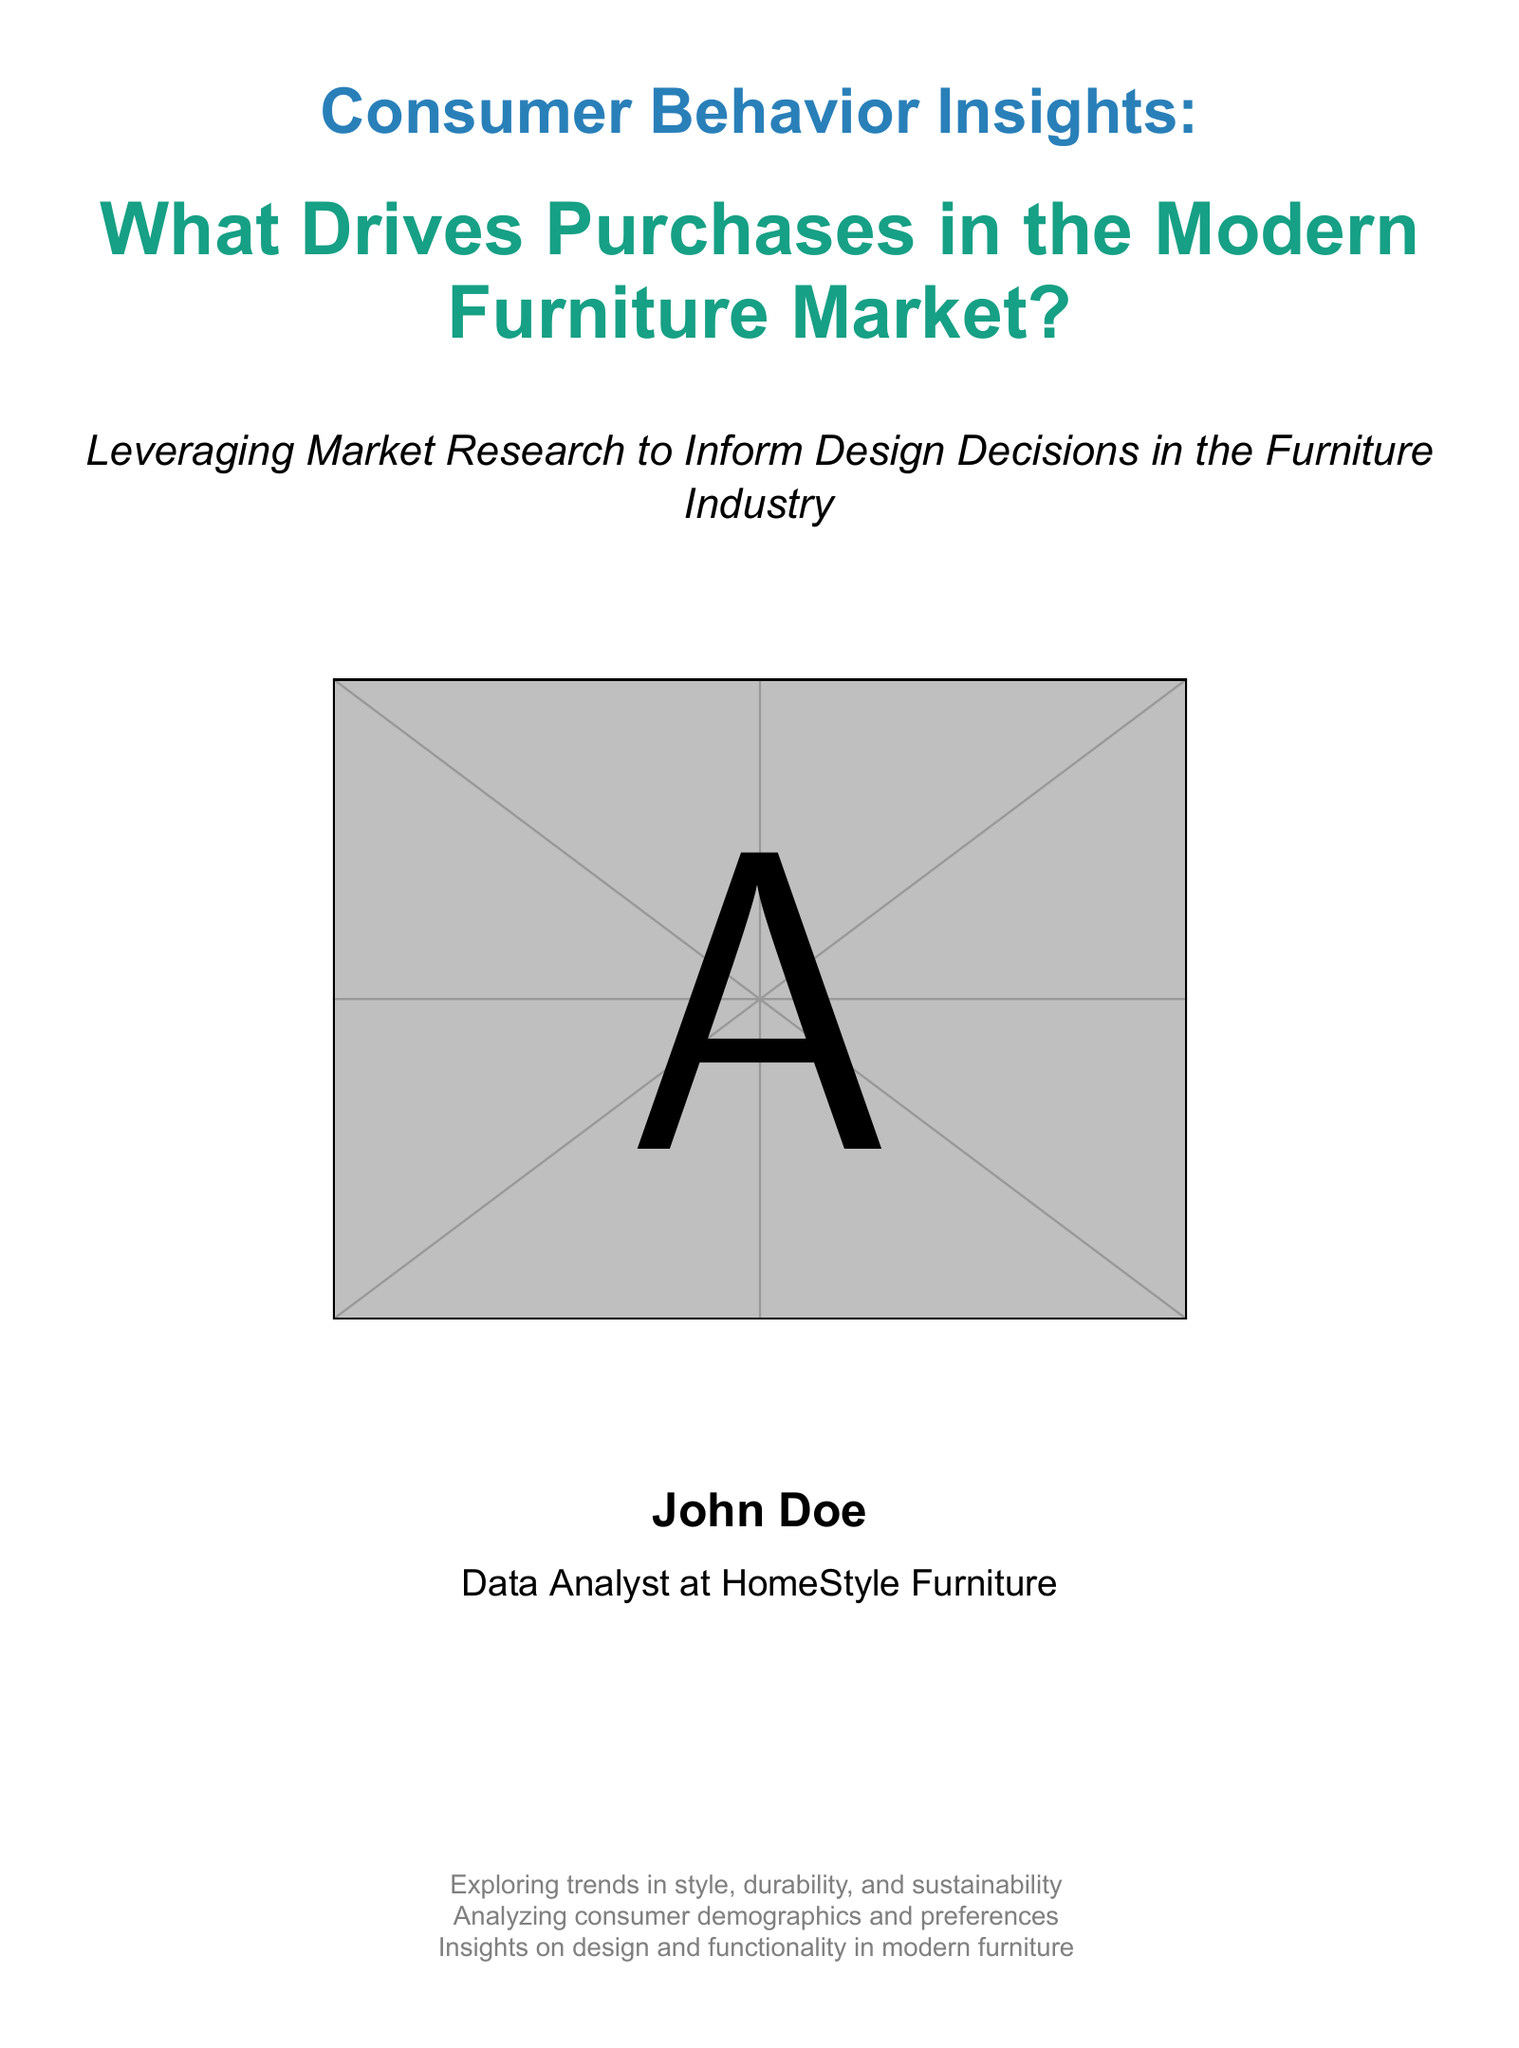What is the title of the book? The title is prominently displayed on the cover, including the main title and subtitle.
Answer: Consumer Behavior Insights: What Drives Purchases in the Modern Furniture Market? Who is the author? The author's name is listed at the bottom of the cover.
Answer: John Doe What is the main theme of the book? The theme is indicated by the subtitle, which explains what the book focuses on.
Answer: Leveraging Market Research to Inform Design Decisions in the Furniture Industry What color is the main title? The color of the main title is specified in the document.
Answer: Cover blue How many key areas are listed in the gray text at the bottom? The number of key areas can be counted from the list provided in the document.
Answer: Three Which company does the author work for? The author's position is mentioned along with the company name.
Answer: HomeStyle Furniture What type of trends does the book explore? The trends are specified in the gray text and indicate specific areas of focus.
Answer: Style, durability, and sustainability What size font is used for the author's title? The font size is consistent with the formatting specified in the document.
Answer: 14pt What is the primary focus of the book cover? The cover emphasizes research insights for design decisions in a specific industry.
Answer: Consumer behavior in the furniture market 